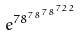Convert formula to latex. <formula><loc_0><loc_0><loc_500><loc_500>e ^ { 7 8 ^ { 7 8 ^ { 7 8 ^ { 7 2 2 } } } }</formula> 